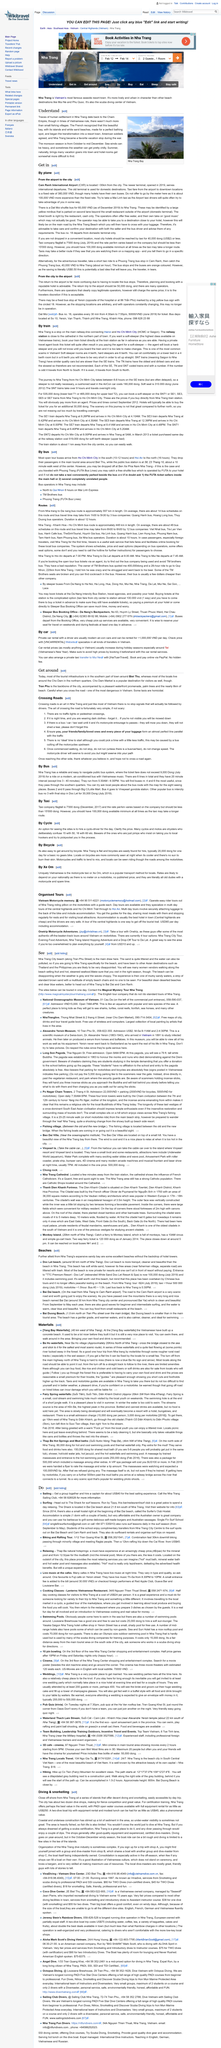Outline some significant characteristics in this image. The fare for a taxi from the airport to a downtown location is a fixed rate of 380,000 VND. It costs approximately 20,000 dong to hire a basic bicycle for one day in Nha Trang, according to the information provided. Soft-sleeper is the highest class of train available on Vietnamese trains, offering a comfortable and luxurious travel experience. It takes approximately 10 to 12 hours by bus to travel from Ho Chi Minh City to Biet Thu. There are approximately two dozen dive shops located in the city. 